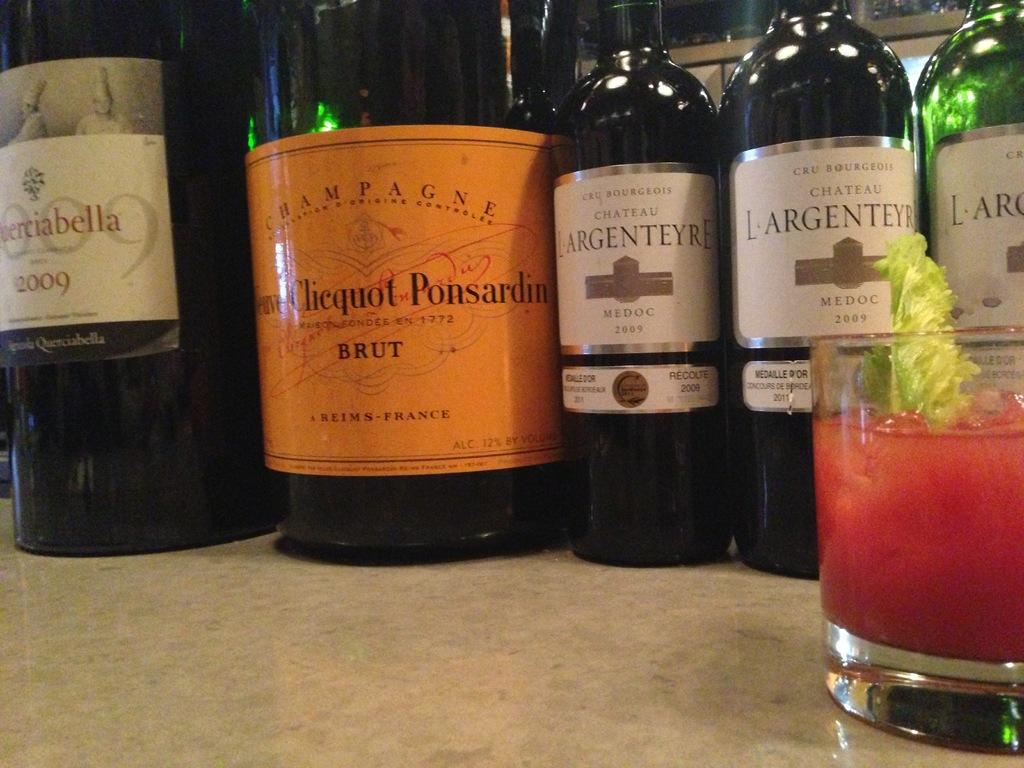What country is the brut from?
Offer a very short reply. France. 